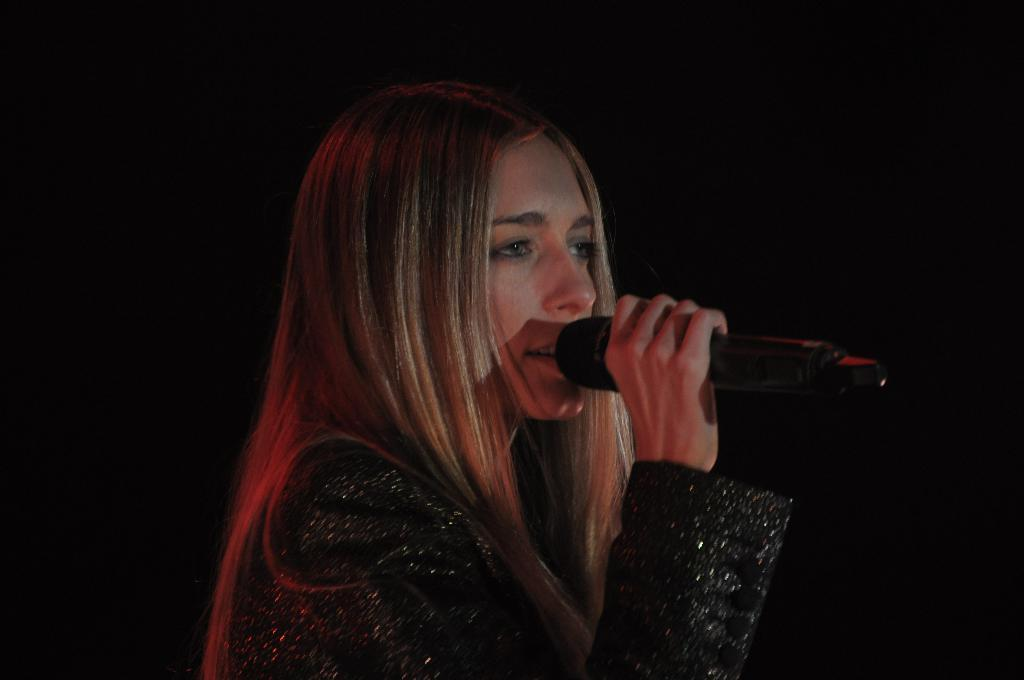Who is the main subject in the image? There is a woman in the image. What is the woman holding in her hand? The woman is holding a microphone in her hand. Is the woman's friend also present in the image? The provided facts do not mention the presence of a friend, so we cannot definitively answer that question. 